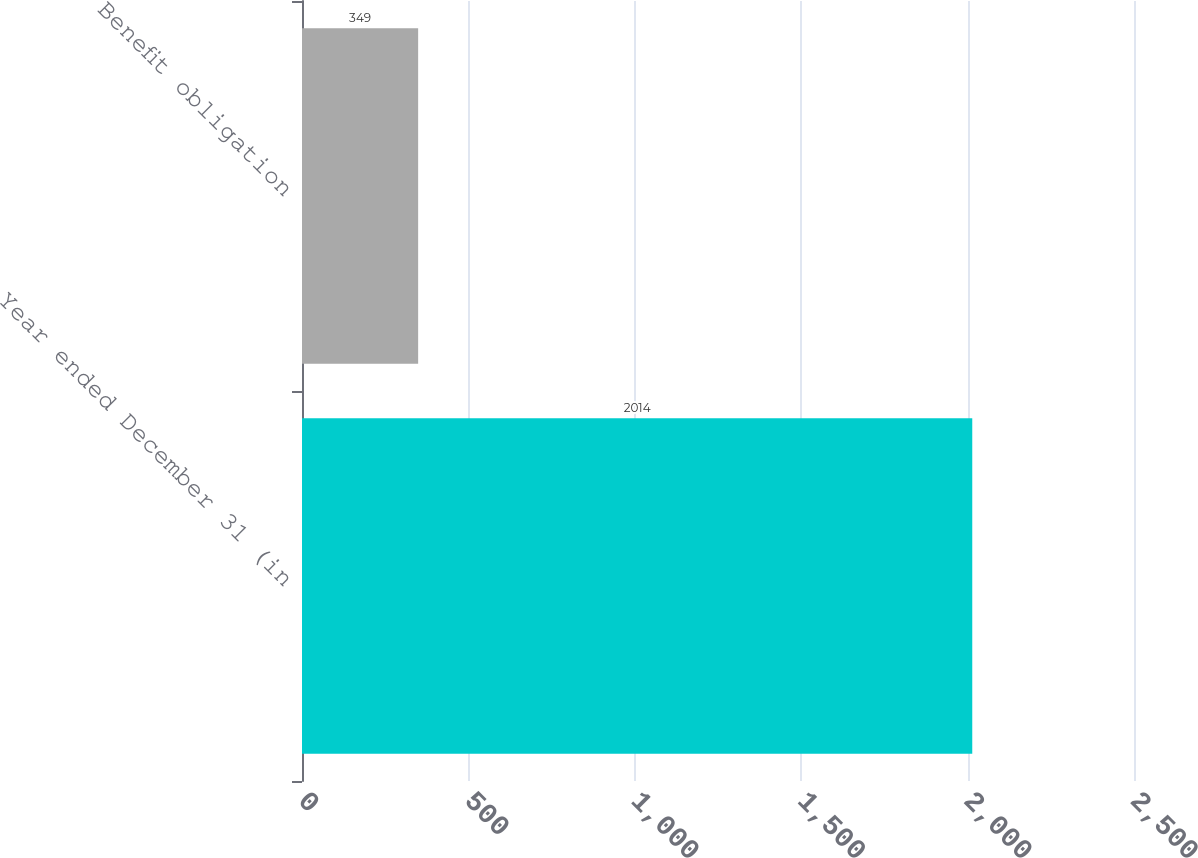Convert chart. <chart><loc_0><loc_0><loc_500><loc_500><bar_chart><fcel>Year ended December 31 (in<fcel>Benefit obligation<nl><fcel>2014<fcel>349<nl></chart> 